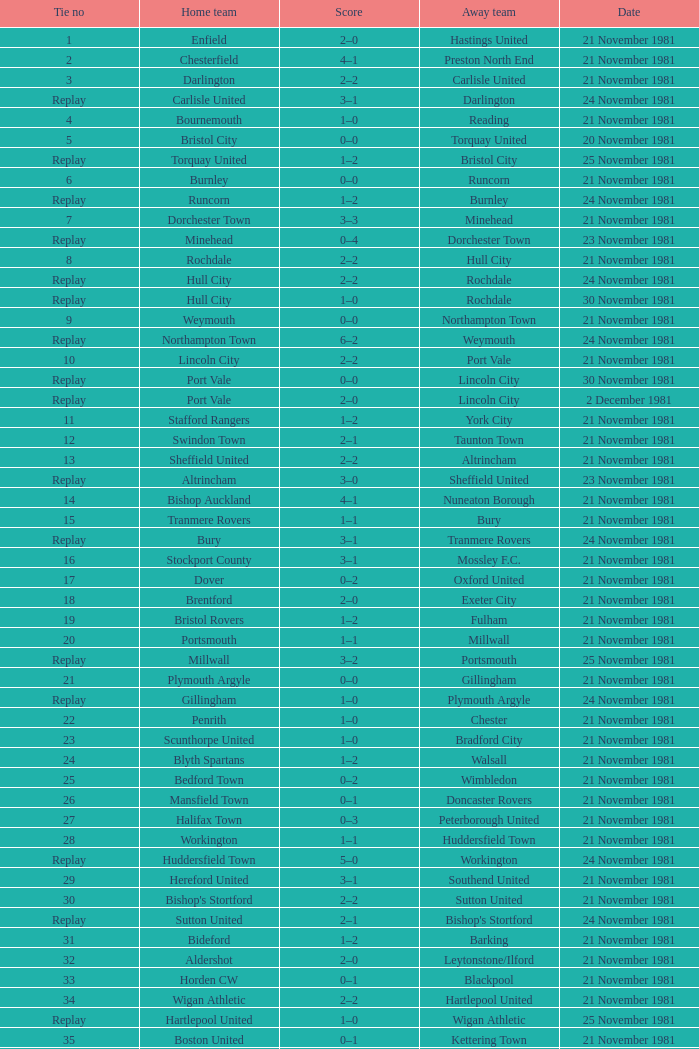On what date was tie number 4? 21 November 1981. 